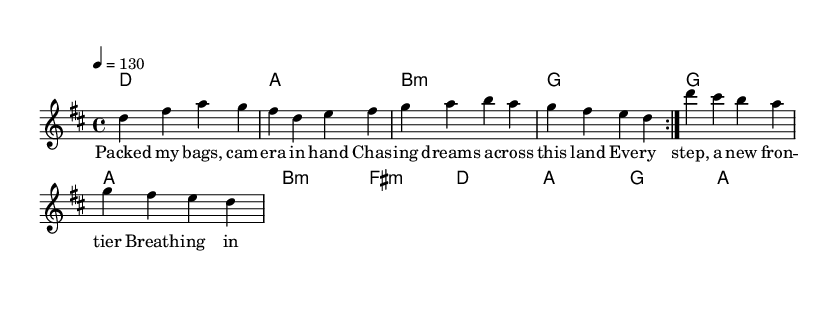What is the key signature of this music? The key signature is indicated by the key signature section at the beginning of the score. Here, it shows two sharps, which correspond to the notes F# and C#. This confirms that the key is D major.
Answer: D major What is the time signature of the piece? The time signature is found close to the beginning of the score, represented by the fraction-like notation. The notation 4/4, which means there are four beats in a measure and the quarter note receives one beat, is visible.
Answer: 4/4 What is the tempo marking for this piece? The tempo is specified with the term "4 = 130." This indicates that there are 130 beats per minute when counting quarter notes.
Answer: 130 How many measures are in the melody section? By looking at the melody section, we can count the number of bar lines that define each measure. The sequence includes eight measures in total before repeating, as indicated by the repeat volta markings.
Answer: 8 What is the first chord in the harmony section? The harmony section begins with the first chord indicated on the staff, shown at the beginning of the chord mode. The first chord is a D major, which is clearly marked.
Answer: D What lyrical theme is presented in this piece? The lyrics describe experiences such as packing bags and chasing dreams, suggesting adventure and exploration. The phrases explicitly convey themes of adventure and seeking new frontiers.
Answer: Chasing dreams What is the structure of the lyrics in the verses? The lyrics are structured into four lines, and each line consists of a phrase that contributes to the central theme of adventure. The layout shows a consistent meter and rhythm, aligning with the melody.
Answer: Four lines 